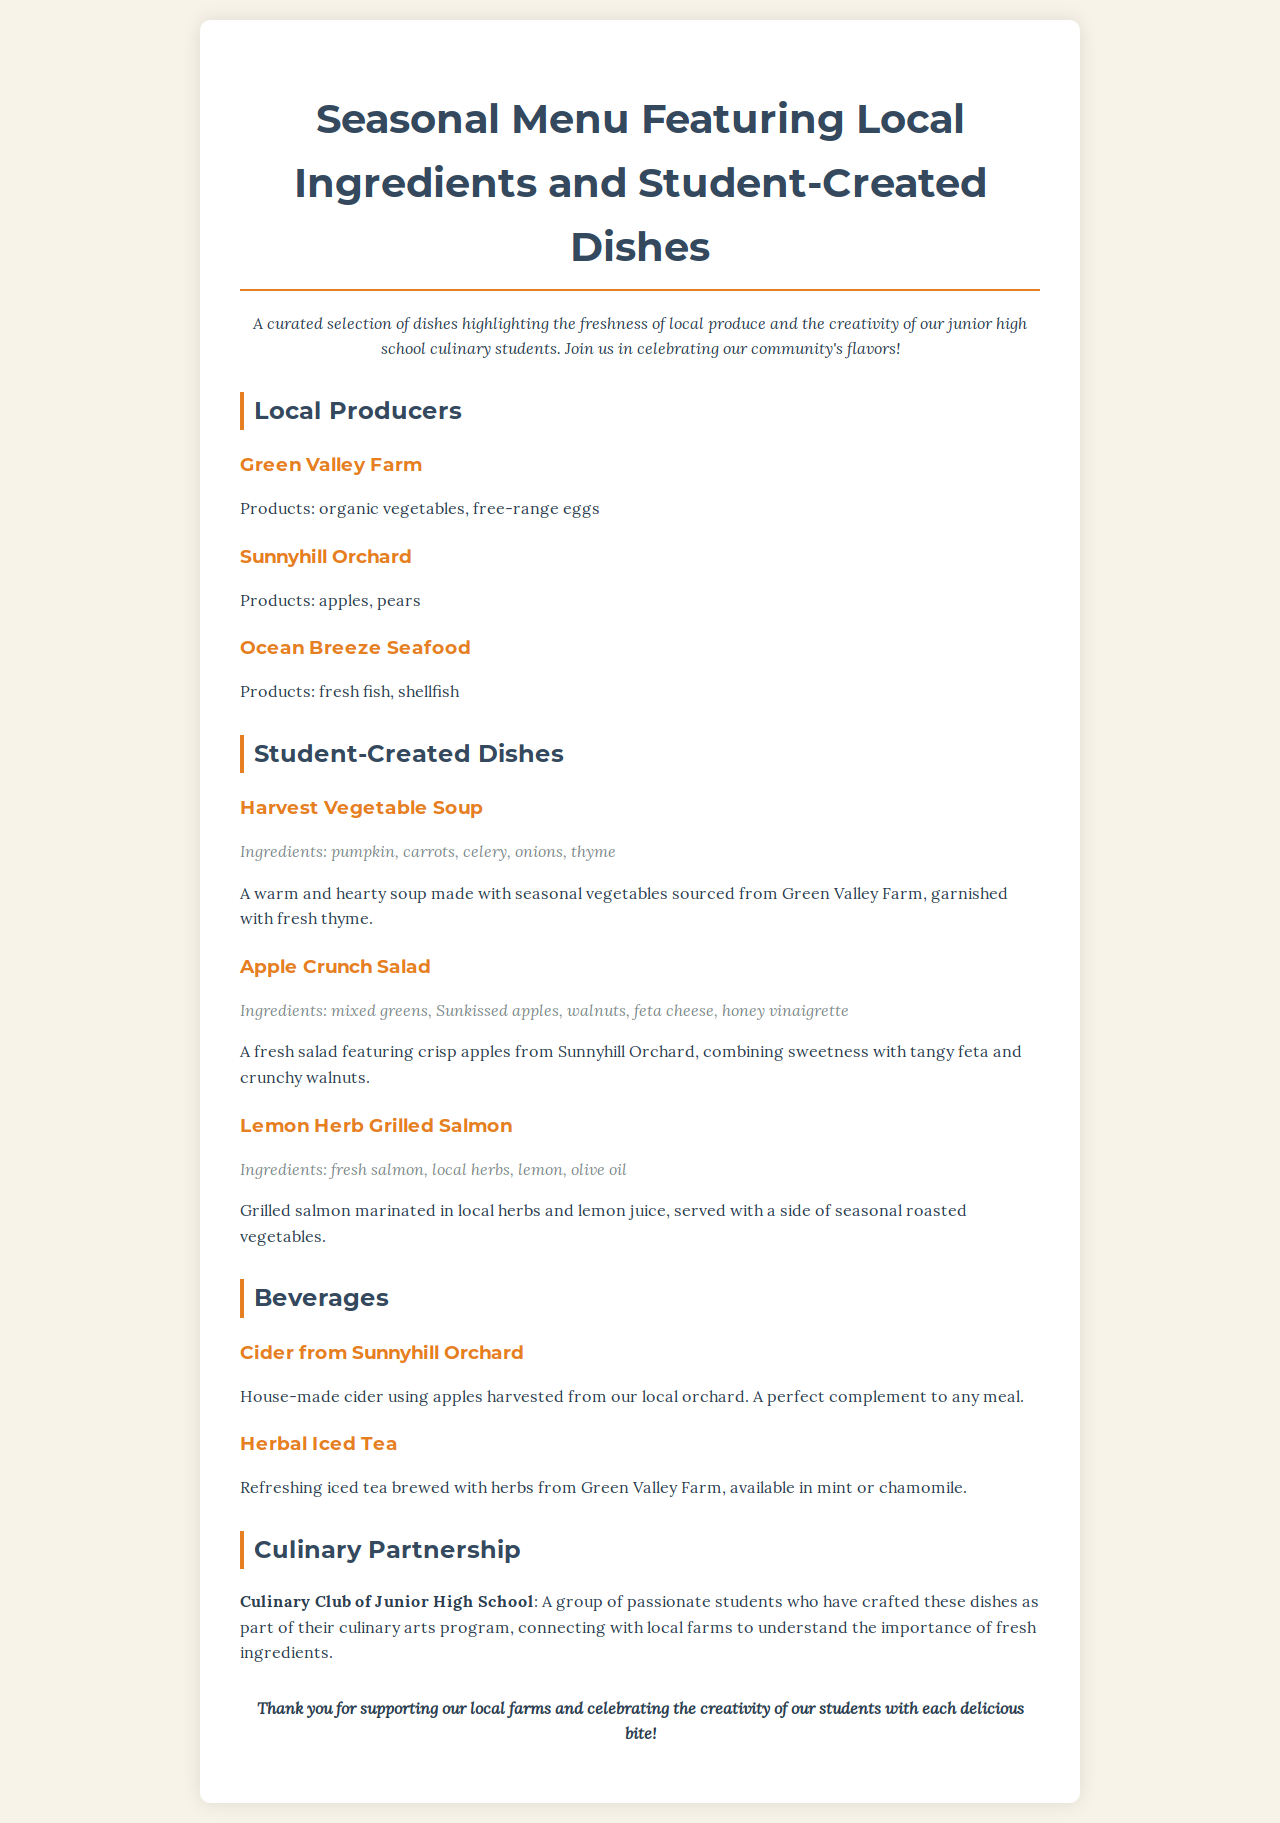what is the title of the menu? The title is displayed prominently at the top of the document, indicating the overall theme and offerings.
Answer: Seasonal Menu Featuring Local Ingredients and Student-Created Dishes who provides the fresh fish and shellfish? The document mentions local producers, highlighting where specific ingredients come from.
Answer: Ocean Breeze Seafood what is one ingredient in the Harvest Vegetable Soup? The ingredients for the soup are listed clearly in the description of the dish.
Answer: pumpkin which drink is made from apples? The beverages section notes a specific drink along with its origin to emphasize local ingredients.
Answer: Cider from Sunnyhill Orchard how many student-created dishes are listed? The document presents a clear section with multiple dishes created by students, allowing easy counting.
Answer: three what type of tea is available in the beverage section? The beverages listed provide options and types of drinks, specifically mentioning brewed tea.
Answer: Herbal Iced Tea which local farm provides organic vegetables? The producers' section lists farms along with their products, clarifying sources for ingredients.
Answer: Green Valley Farm what is the main protein in the Lemon Herb Grilled Salmon dish? The dish description explicitly states the primary protein used in the creation of the dish.
Answer: salmon 